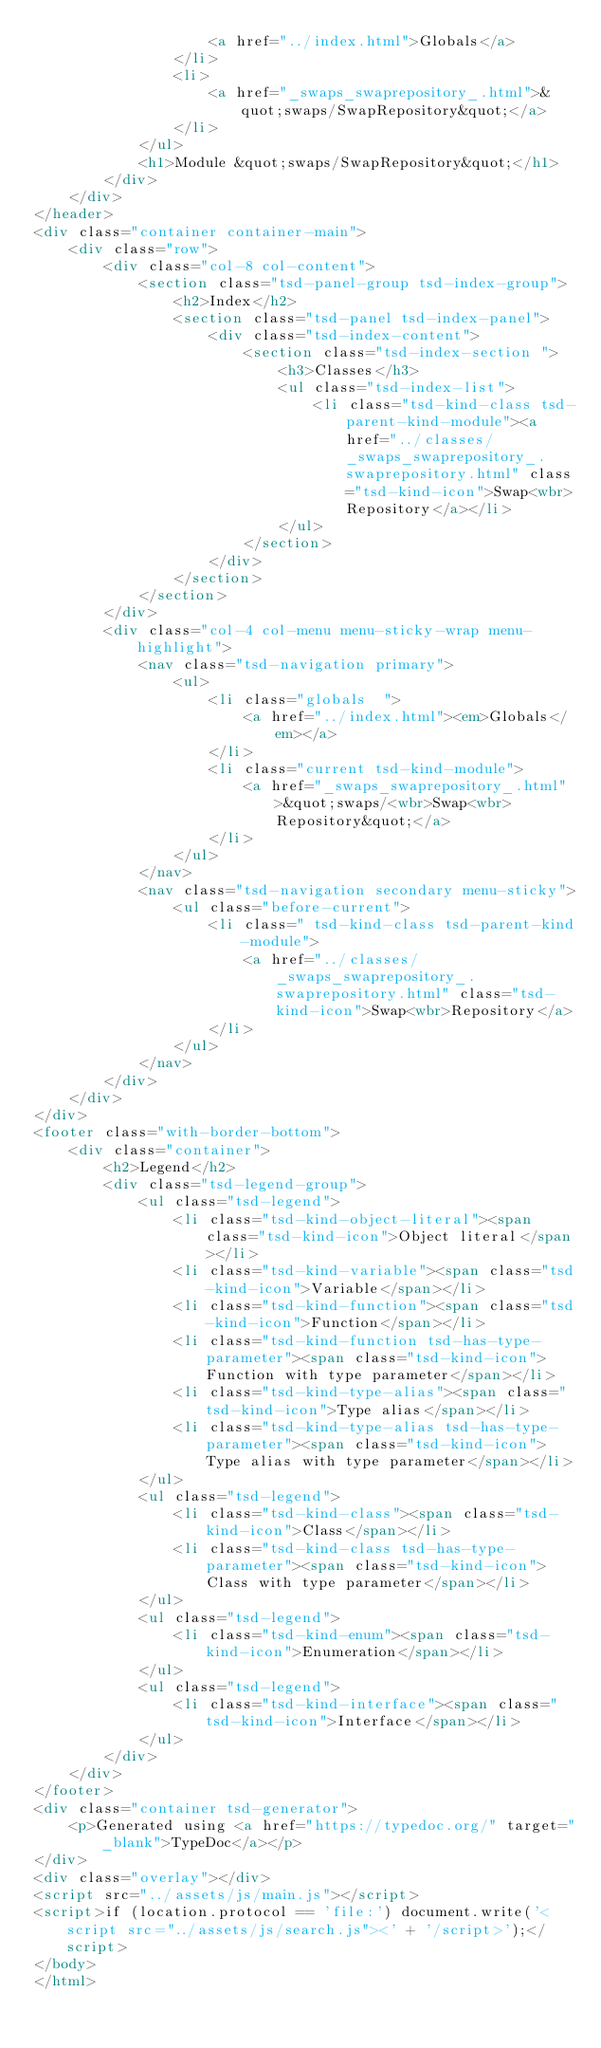Convert code to text. <code><loc_0><loc_0><loc_500><loc_500><_HTML_>					<a href="../index.html">Globals</a>
				</li>
				<li>
					<a href="_swaps_swaprepository_.html">&quot;swaps/SwapRepository&quot;</a>
				</li>
			</ul>
			<h1>Module &quot;swaps/SwapRepository&quot;</h1>
		</div>
	</div>
</header>
<div class="container container-main">
	<div class="row">
		<div class="col-8 col-content">
			<section class="tsd-panel-group tsd-index-group">
				<h2>Index</h2>
				<section class="tsd-panel tsd-index-panel">
					<div class="tsd-index-content">
						<section class="tsd-index-section ">
							<h3>Classes</h3>
							<ul class="tsd-index-list">
								<li class="tsd-kind-class tsd-parent-kind-module"><a href="../classes/_swaps_swaprepository_.swaprepository.html" class="tsd-kind-icon">Swap<wbr>Repository</a></li>
							</ul>
						</section>
					</div>
				</section>
			</section>
		</div>
		<div class="col-4 col-menu menu-sticky-wrap menu-highlight">
			<nav class="tsd-navigation primary">
				<ul>
					<li class="globals  ">
						<a href="../index.html"><em>Globals</em></a>
					</li>
					<li class="current tsd-kind-module">
						<a href="_swaps_swaprepository_.html">&quot;swaps/<wbr>Swap<wbr>Repository&quot;</a>
					</li>
				</ul>
			</nav>
			<nav class="tsd-navigation secondary menu-sticky">
				<ul class="before-current">
					<li class=" tsd-kind-class tsd-parent-kind-module">
						<a href="../classes/_swaps_swaprepository_.swaprepository.html" class="tsd-kind-icon">Swap<wbr>Repository</a>
					</li>
				</ul>
			</nav>
		</div>
	</div>
</div>
<footer class="with-border-bottom">
	<div class="container">
		<h2>Legend</h2>
		<div class="tsd-legend-group">
			<ul class="tsd-legend">
				<li class="tsd-kind-object-literal"><span class="tsd-kind-icon">Object literal</span></li>
				<li class="tsd-kind-variable"><span class="tsd-kind-icon">Variable</span></li>
				<li class="tsd-kind-function"><span class="tsd-kind-icon">Function</span></li>
				<li class="tsd-kind-function tsd-has-type-parameter"><span class="tsd-kind-icon">Function with type parameter</span></li>
				<li class="tsd-kind-type-alias"><span class="tsd-kind-icon">Type alias</span></li>
				<li class="tsd-kind-type-alias tsd-has-type-parameter"><span class="tsd-kind-icon">Type alias with type parameter</span></li>
			</ul>
			<ul class="tsd-legend">
				<li class="tsd-kind-class"><span class="tsd-kind-icon">Class</span></li>
				<li class="tsd-kind-class tsd-has-type-parameter"><span class="tsd-kind-icon">Class with type parameter</span></li>
			</ul>
			<ul class="tsd-legend">
				<li class="tsd-kind-enum"><span class="tsd-kind-icon">Enumeration</span></li>
			</ul>
			<ul class="tsd-legend">
				<li class="tsd-kind-interface"><span class="tsd-kind-icon">Interface</span></li>
			</ul>
		</div>
	</div>
</footer>
<div class="container tsd-generator">
	<p>Generated using <a href="https://typedoc.org/" target="_blank">TypeDoc</a></p>
</div>
<div class="overlay"></div>
<script src="../assets/js/main.js"></script>
<script>if (location.protocol == 'file:') document.write('<script src="../assets/js/search.js"><' + '/script>');</script>
</body>
</html></code> 